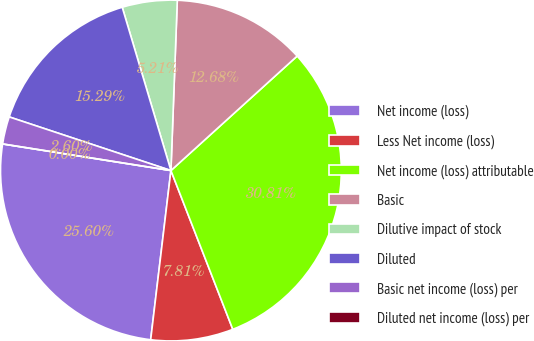Convert chart to OTSL. <chart><loc_0><loc_0><loc_500><loc_500><pie_chart><fcel>Net income (loss)<fcel>Less Net income (loss)<fcel>Net income (loss) attributable<fcel>Basic<fcel>Dilutive impact of stock<fcel>Diluted<fcel>Basic net income (loss) per<fcel>Diluted net income (loss) per<nl><fcel>25.6%<fcel>7.81%<fcel>30.81%<fcel>12.68%<fcel>5.21%<fcel>15.29%<fcel>2.6%<fcel>0.0%<nl></chart> 